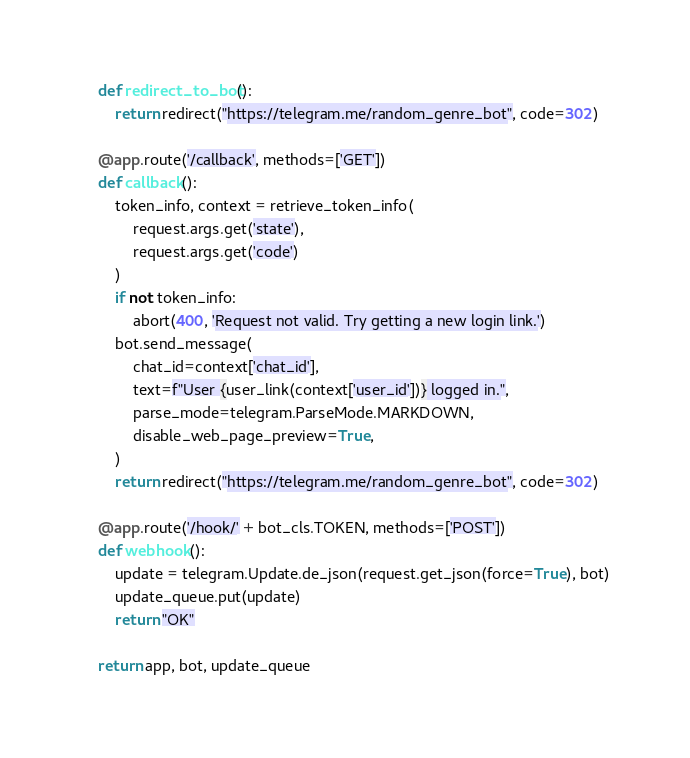<code> <loc_0><loc_0><loc_500><loc_500><_Python_>    def redirect_to_bot():
        return redirect("https://telegram.me/random_genre_bot", code=302)

    @app.route('/callback', methods=['GET'])
    def callback():
        token_info, context = retrieve_token_info(
            request.args.get('state'),
            request.args.get('code')
        )
        if not token_info:
            abort(400, 'Request not valid. Try getting a new login link.')
        bot.send_message(
            chat_id=context['chat_id'],
            text=f"User {user_link(context['user_id'])} logged in.",
            parse_mode=telegram.ParseMode.MARKDOWN,
            disable_web_page_preview=True,
        )
        return redirect("https://telegram.me/random_genre_bot", code=302)

    @app.route('/hook/' + bot_cls.TOKEN, methods=['POST'])
    def webhook():
        update = telegram.Update.de_json(request.get_json(force=True), bot)
        update_queue.put(update)
        return "OK"

    return app, bot, update_queue
</code> 